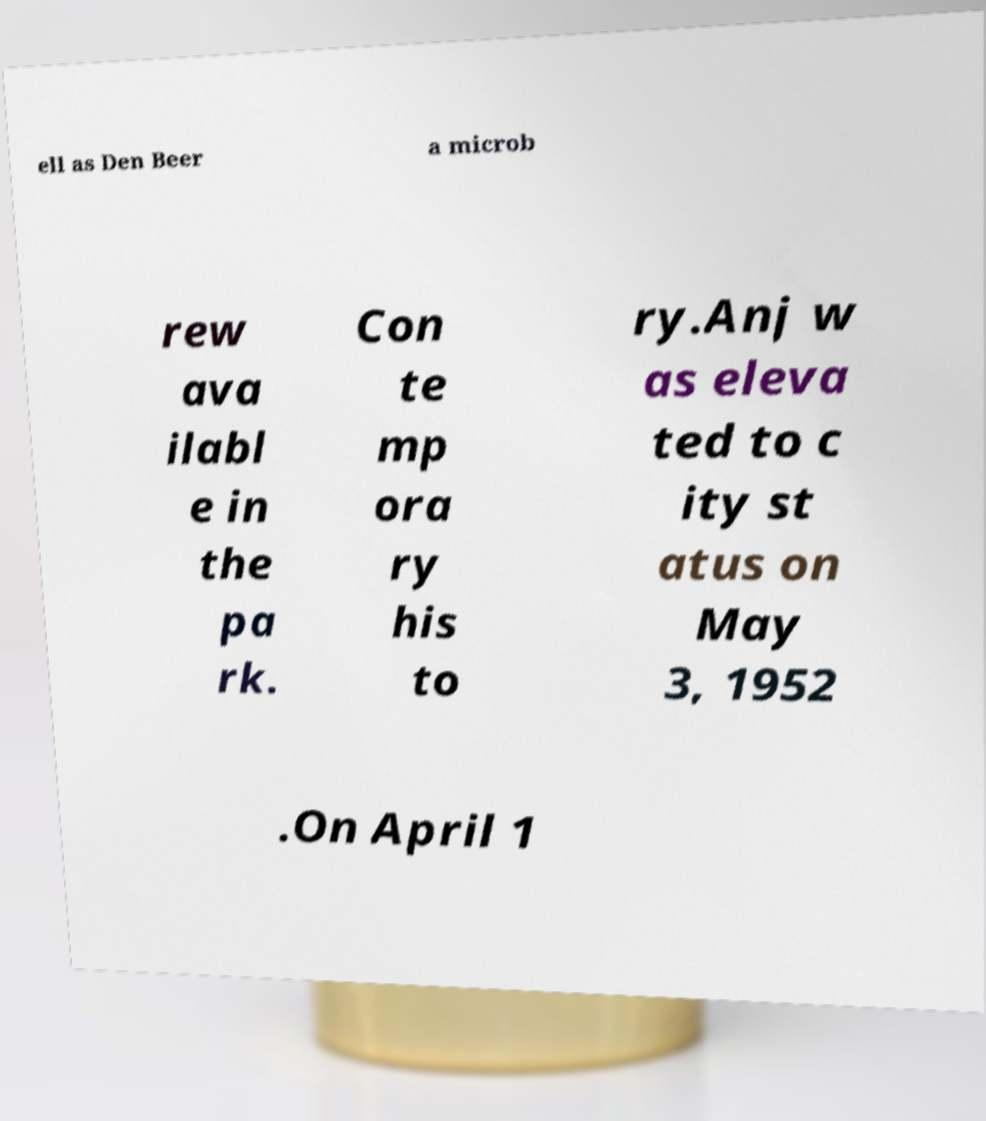There's text embedded in this image that I need extracted. Can you transcribe it verbatim? ell as Den Beer a microb rew ava ilabl e in the pa rk. Con te mp ora ry his to ry.Anj w as eleva ted to c ity st atus on May 3, 1952 .On April 1 